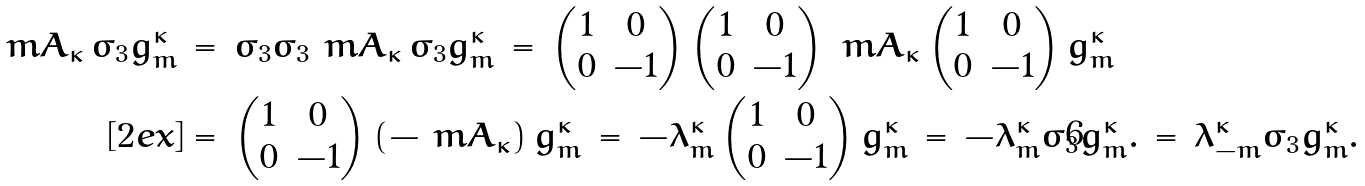<formula> <loc_0><loc_0><loc_500><loc_500>\ m A _ { \kappa } \, \sigma _ { 3 } g _ { m } ^ { \kappa } \, & = \, \sigma _ { 3 } \sigma _ { 3 } \ m A _ { \kappa } \, \sigma _ { 3 } g _ { m } ^ { \kappa } \, = \, \begin{pmatrix} 1 & 0 \\ 0 & - 1 \end{pmatrix} \begin{pmatrix} 1 & 0 \\ 0 & - 1 \end{pmatrix} \ m A _ { \kappa } \begin{pmatrix} 1 & 0 \\ 0 & - 1 \end{pmatrix} g _ { m } ^ { \kappa } \\ [ 2 e x ] & = \, \begin{pmatrix} 1 & 0 \\ 0 & - 1 \end{pmatrix} ( - \ m A _ { \kappa } ) \, g _ { m } ^ { \kappa } \, = \, - \lambda _ { m } ^ { \kappa } \begin{pmatrix} 1 & 0 \\ 0 & - 1 \end{pmatrix} g _ { m } ^ { \kappa } \, = \, - \lambda _ { m } ^ { \kappa } \sigma _ { 3 } g _ { m } ^ { \kappa } . \, = \, \lambda _ { - m } ^ { \kappa } \sigma _ { 3 } g _ { m } ^ { \kappa } .</formula> 